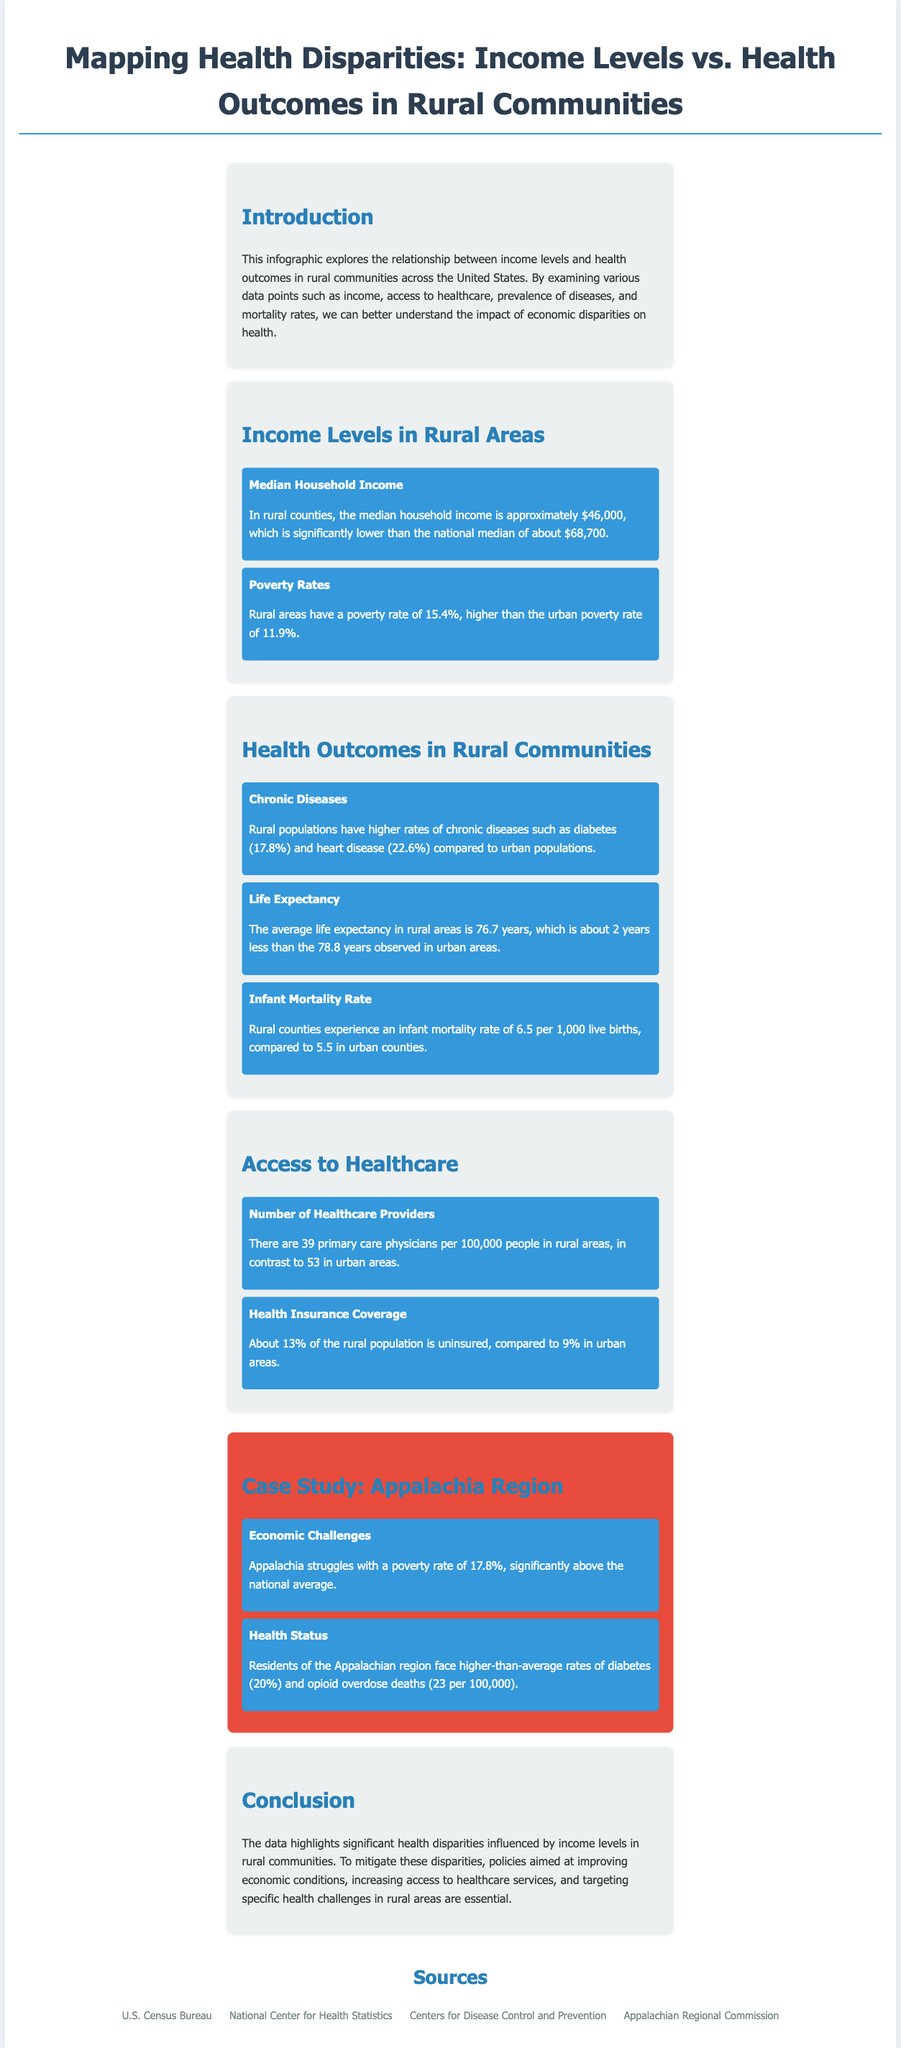What is the median household income in rural counties? The document states that the median household income in rural counties is approximately $46,000.
Answer: $46,000 What is the poverty rate in rural areas? According to the infographic, rural areas have a poverty rate of 15.4%.
Answer: 15.4% What is the average life expectancy in rural areas? The document mentions that the average life expectancy in rural areas is 76.7 years.
Answer: 76.7 years How many primary care physicians are there per 100,000 people in rural areas? The document provides that there are 39 primary care physicians per 100,000 people in rural areas.
Answer: 39 What chronic disease has the highest prevalence in rural populations? The infographic indicates that heart disease has a prevalence of 22.6%, which is higher than diabetes.
Answer: Heart disease What is the infant mortality rate in rural counties? The document states that rural counties experience an infant mortality rate of 6.5 per 1,000 live births.
Answer: 6.5 per 1,000 What region is specifically discussed in the case study? The case study focuses on the Appalachia region.
Answer: Appalachia How does the poverty rate in Appalachia compare to the national average? According to the case study, Appalachia has a poverty rate that is significantly above the national average.
Answer: Above the national average What health issue is emphasized in the Appalachia region? The data highlights that residents of the Appalachian region face higher-than-average rates of diabetes.
Answer: Higher-than-average rates of diabetes 